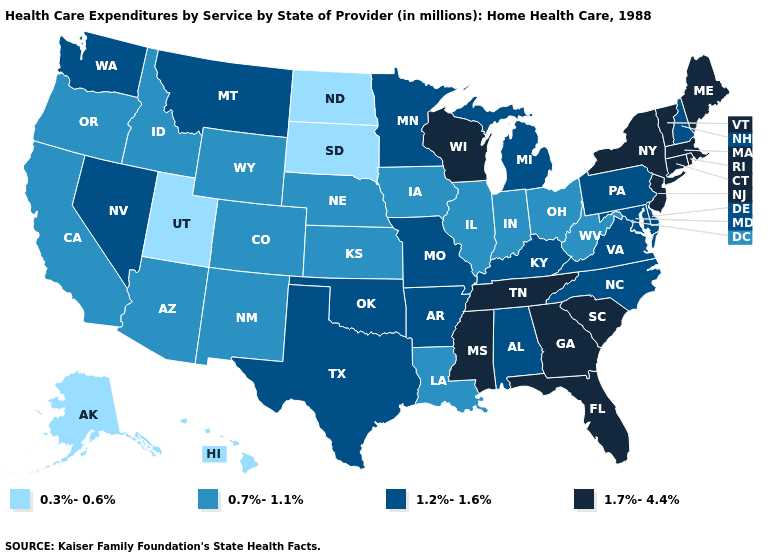Among the states that border Michigan , which have the lowest value?
Keep it brief. Indiana, Ohio. Name the states that have a value in the range 0.3%-0.6%?
Short answer required. Alaska, Hawaii, North Dakota, South Dakota, Utah. Name the states that have a value in the range 0.7%-1.1%?
Write a very short answer. Arizona, California, Colorado, Idaho, Illinois, Indiana, Iowa, Kansas, Louisiana, Nebraska, New Mexico, Ohio, Oregon, West Virginia, Wyoming. Name the states that have a value in the range 1.2%-1.6%?
Answer briefly. Alabama, Arkansas, Delaware, Kentucky, Maryland, Michigan, Minnesota, Missouri, Montana, Nevada, New Hampshire, North Carolina, Oklahoma, Pennsylvania, Texas, Virginia, Washington. What is the highest value in states that border Connecticut?
Answer briefly. 1.7%-4.4%. Does the map have missing data?
Write a very short answer. No. Does Missouri have a lower value than New Hampshire?
Give a very brief answer. No. What is the highest value in the USA?
Be succinct. 1.7%-4.4%. What is the value of Indiana?
Quick response, please. 0.7%-1.1%. Which states have the lowest value in the MidWest?
Write a very short answer. North Dakota, South Dakota. What is the value of Nebraska?
Quick response, please. 0.7%-1.1%. Name the states that have a value in the range 0.3%-0.6%?
Short answer required. Alaska, Hawaii, North Dakota, South Dakota, Utah. Does the map have missing data?
Answer briefly. No. What is the lowest value in the USA?
Answer briefly. 0.3%-0.6%. 